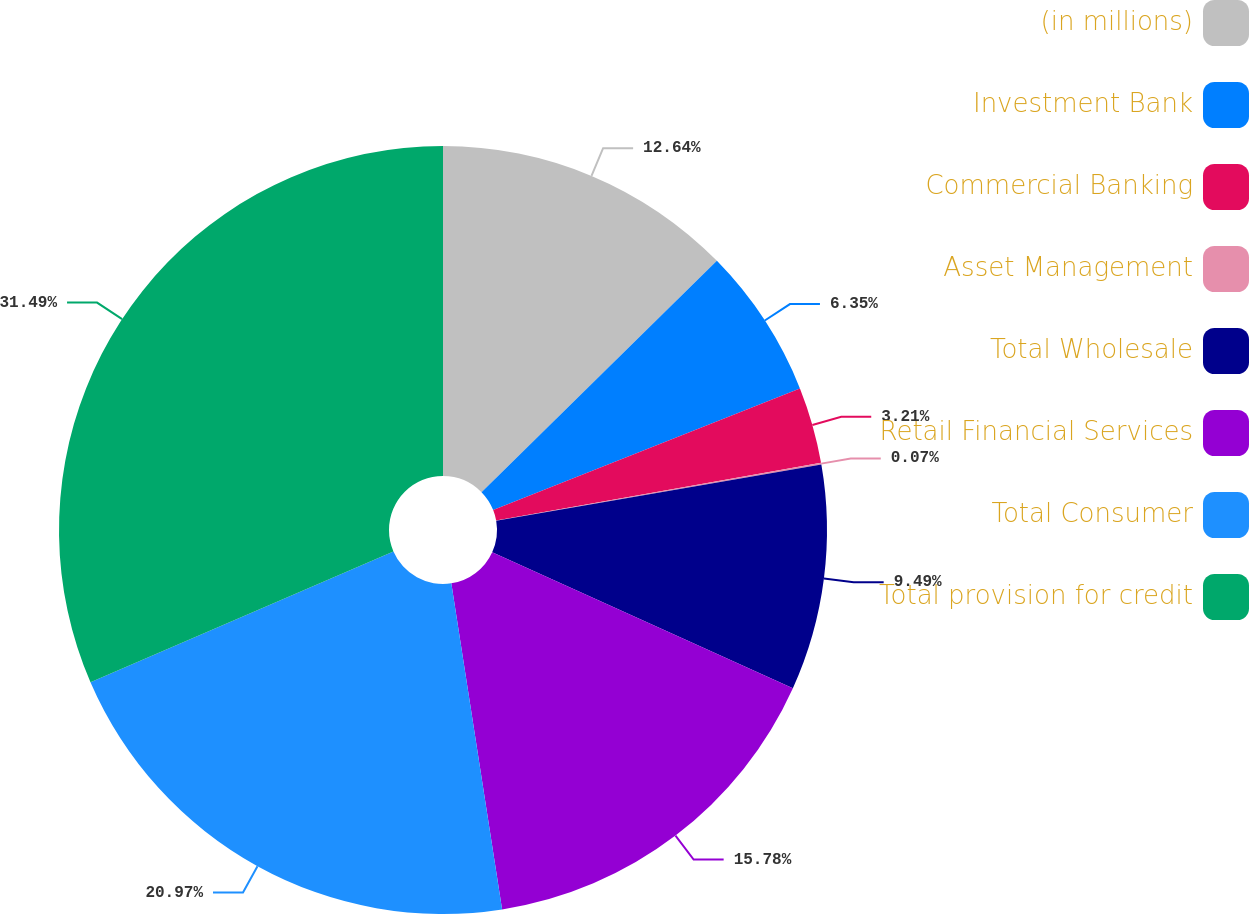Convert chart. <chart><loc_0><loc_0><loc_500><loc_500><pie_chart><fcel>(in millions)<fcel>Investment Bank<fcel>Commercial Banking<fcel>Asset Management<fcel>Total Wholesale<fcel>Retail Financial Services<fcel>Total Consumer<fcel>Total provision for credit<nl><fcel>12.64%<fcel>6.35%<fcel>3.21%<fcel>0.07%<fcel>9.49%<fcel>15.78%<fcel>20.97%<fcel>31.49%<nl></chart> 